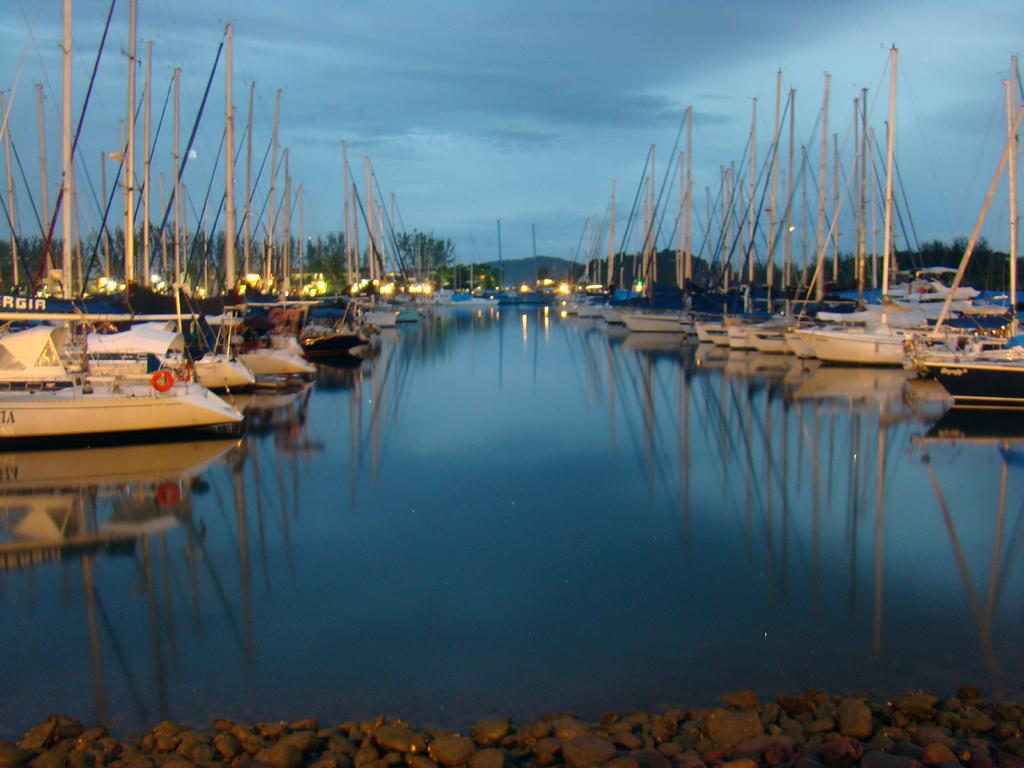What is the main subject of the image? The main subject of the image is ships. Where are the ships located? The ships are on a river. How are the ships arranged in the image? The ships are arranged in an order. What can be seen in the background of the image? There are trees and light sand visible in the background, along with lights. What type of honey is being collected by the hat in the image? There is no honey or hat present in the image. How is the knot tied on the ship's rope in the image? There is no knot or rope visible on the ships in the image. 